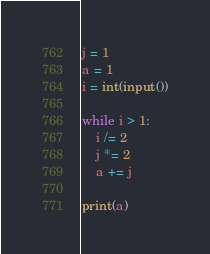<code> <loc_0><loc_0><loc_500><loc_500><_Python_>j = 1
a = 1
i = int(input())

while i > 1:
    i /= 2
    j *= 2
    a += j

print(a)</code> 